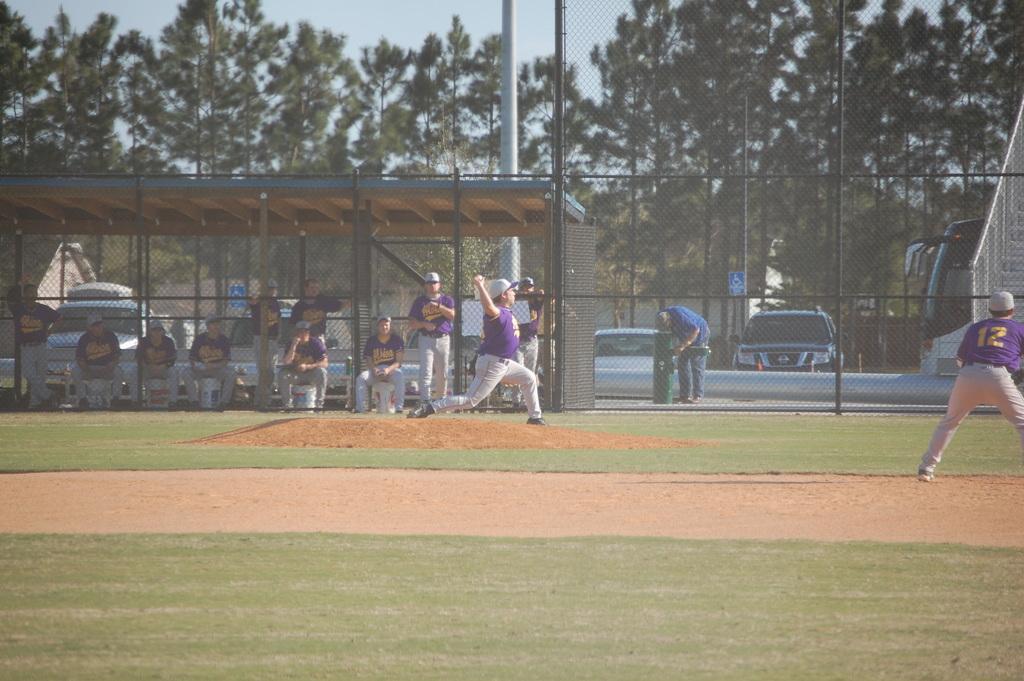Could you give a brief overview of what you see in this image? In the picture I can see two baseball players standing on the ground and I can see one of them holding the ball in his right hand. I can see a few baseball players sitting on the chairs on the left side. I can see a metal shed construction on the left side. In the background, I can see the metal fence, cars and trees. 